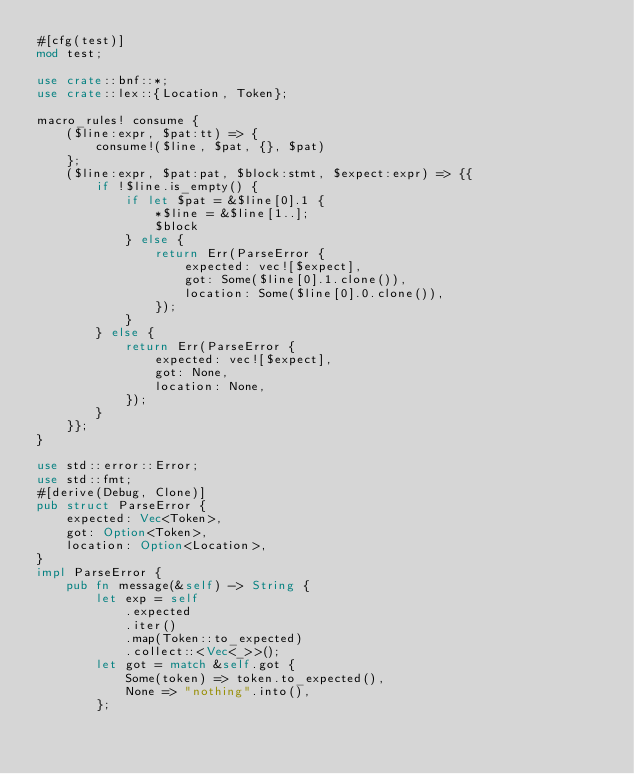<code> <loc_0><loc_0><loc_500><loc_500><_Rust_>#[cfg(test)]
mod test;

use crate::bnf::*;
use crate::lex::{Location, Token};

macro_rules! consume {
    ($line:expr, $pat:tt) => {
        consume!($line, $pat, {}, $pat)
    };
    ($line:expr, $pat:pat, $block:stmt, $expect:expr) => {{
        if !$line.is_empty() {
            if let $pat = &$line[0].1 {
                *$line = &$line[1..];
                $block
            } else {
                return Err(ParseError {
                    expected: vec![$expect],
                    got: Some($line[0].1.clone()),
                    location: Some($line[0].0.clone()),
                });
            }
        } else {
            return Err(ParseError {
                expected: vec![$expect],
                got: None,
                location: None,
            });
        }
    }};
}

use std::error::Error;
use std::fmt;
#[derive(Debug, Clone)]
pub struct ParseError {
    expected: Vec<Token>,
    got: Option<Token>,
    location: Option<Location>,
}
impl ParseError {
    pub fn message(&self) -> String {
        let exp = self
            .expected
            .iter()
            .map(Token::to_expected)
            .collect::<Vec<_>>();
        let got = match &self.got {
            Some(token) => token.to_expected(),
            None => "nothing".into(),
        };
</code> 